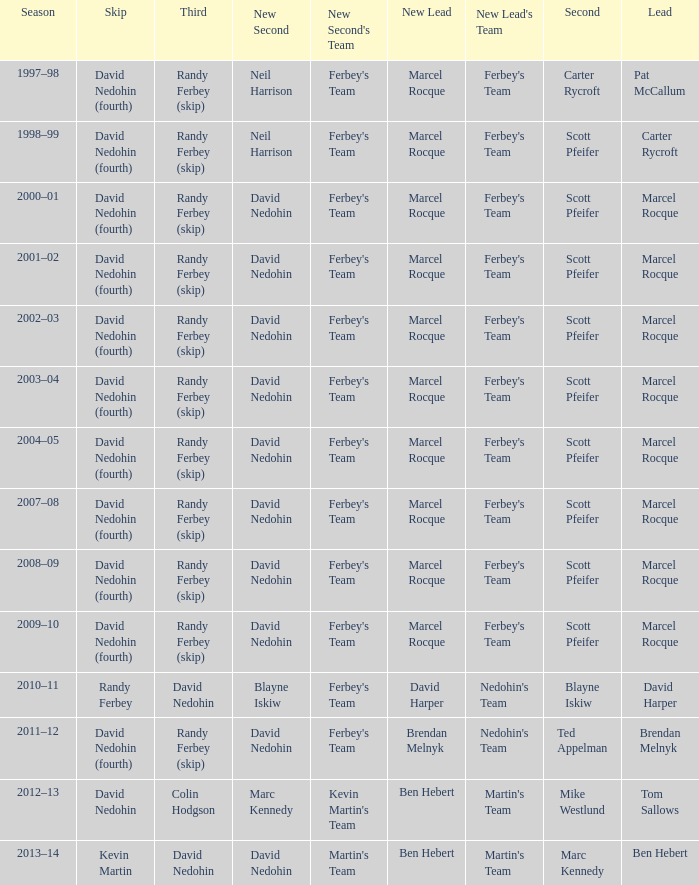Which Lead has a Third of randy ferbey (skip), a Second of scott pfeifer, and a Season of 2009–10? Marcel Rocque. Would you mind parsing the complete table? {'header': ['Season', 'Skip', 'Third', 'New Second', "New Second's Team", 'New Lead', "New Lead's Team", 'Second', 'Lead'], 'rows': [['1997–98', 'David Nedohin (fourth)', 'Randy Ferbey (skip)', 'Neil Harrison', "Ferbey's Team", 'Marcel Rocque', "Ferbey's Team", 'Carter Rycroft', 'Pat McCallum'], ['1998–99', 'David Nedohin (fourth)', 'Randy Ferbey (skip)', 'Neil Harrison', "Ferbey's Team", 'Marcel Rocque', "Ferbey's Team", 'Scott Pfeifer', 'Carter Rycroft'], ['2000–01', 'David Nedohin (fourth)', 'Randy Ferbey (skip)', 'David Nedohin', "Ferbey's Team", 'Marcel Rocque', "Ferbey's Team", 'Scott Pfeifer', 'Marcel Rocque'], ['2001–02', 'David Nedohin (fourth)', 'Randy Ferbey (skip)', 'David Nedohin', "Ferbey's Team", 'Marcel Rocque', "Ferbey's Team", 'Scott Pfeifer', 'Marcel Rocque'], ['2002–03', 'David Nedohin (fourth)', 'Randy Ferbey (skip)', 'David Nedohin', "Ferbey's Team", 'Marcel Rocque', "Ferbey's Team", 'Scott Pfeifer', 'Marcel Rocque'], ['2003–04', 'David Nedohin (fourth)', 'Randy Ferbey (skip)', 'David Nedohin', "Ferbey's Team", 'Marcel Rocque', "Ferbey's Team", 'Scott Pfeifer', 'Marcel Rocque'], ['2004–05', 'David Nedohin (fourth)', 'Randy Ferbey (skip)', 'David Nedohin', "Ferbey's Team", 'Marcel Rocque', "Ferbey's Team", 'Scott Pfeifer', 'Marcel Rocque'], ['2007–08', 'David Nedohin (fourth)', 'Randy Ferbey (skip)', 'David Nedohin', "Ferbey's Team", 'Marcel Rocque', "Ferbey's Team", 'Scott Pfeifer', 'Marcel Rocque'], ['2008–09', 'David Nedohin (fourth)', 'Randy Ferbey (skip)', 'David Nedohin', "Ferbey's Team", 'Marcel Rocque', "Ferbey's Team", 'Scott Pfeifer', 'Marcel Rocque'], ['2009–10', 'David Nedohin (fourth)', 'Randy Ferbey (skip)', 'David Nedohin', "Ferbey's Team", 'Marcel Rocque', "Ferbey's Team", 'Scott Pfeifer', 'Marcel Rocque'], ['2010–11', 'Randy Ferbey', 'David Nedohin', 'Blayne Iskiw', "Ferbey's Team", 'David Harper', "Nedohin's Team", 'Blayne Iskiw', 'David Harper'], ['2011–12', 'David Nedohin (fourth)', 'Randy Ferbey (skip)', 'David Nedohin', "Ferbey's Team", 'Brendan Melnyk', "Nedohin's Team", 'Ted Appelman', 'Brendan Melnyk'], ['2012–13', 'David Nedohin', 'Colin Hodgson', 'Marc Kennedy', "Kevin Martin's Team", 'Ben Hebert', "Martin's Team", 'Mike Westlund', 'Tom Sallows'], ['2013–14', 'Kevin Martin', 'David Nedohin', 'David Nedohin', "Martin's Team", 'Ben Hebert', "Martin's Team", 'Marc Kennedy', 'Ben Hebert']]} 